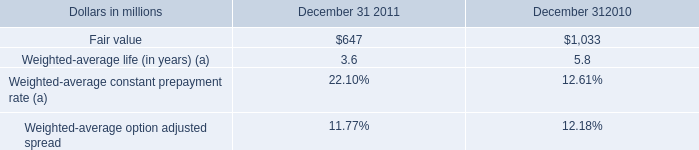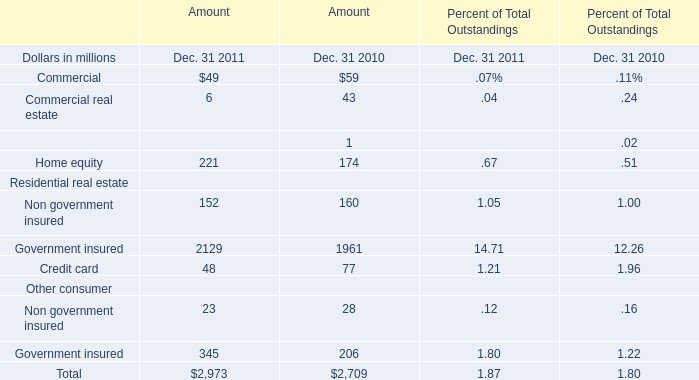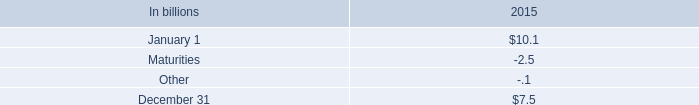What was the sum of Commercial without those Commercial smaller than 100 for amount ? (in million) 
Computations: (49 + 59)
Answer: 108.0. 